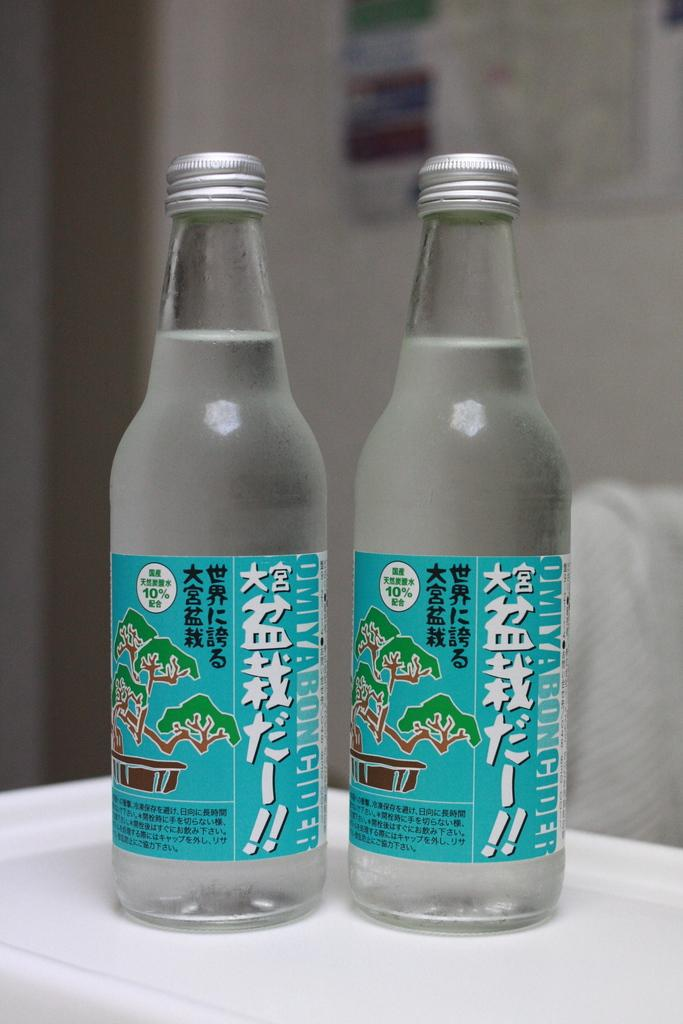Provide a one-sentence caption for the provided image. two bottles of Omiyaboncider that contains 10% of something. 